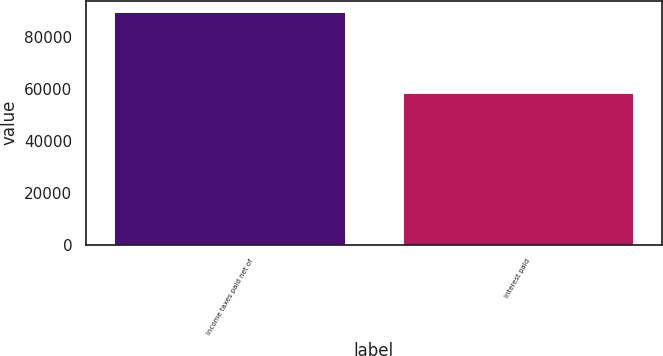<chart> <loc_0><loc_0><loc_500><loc_500><bar_chart><fcel>Income taxes paid net of<fcel>Interest paid<nl><fcel>89684<fcel>58730<nl></chart> 